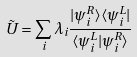<formula> <loc_0><loc_0><loc_500><loc_500>\tilde { U } = \sum _ { i } \lambda _ { i } \frac { | \psi ^ { R } _ { i } \rangle \langle \psi ^ { L } _ { i } | } { \langle \psi ^ { L } _ { i } | \psi ^ { R } _ { i } \rangle }</formula> 